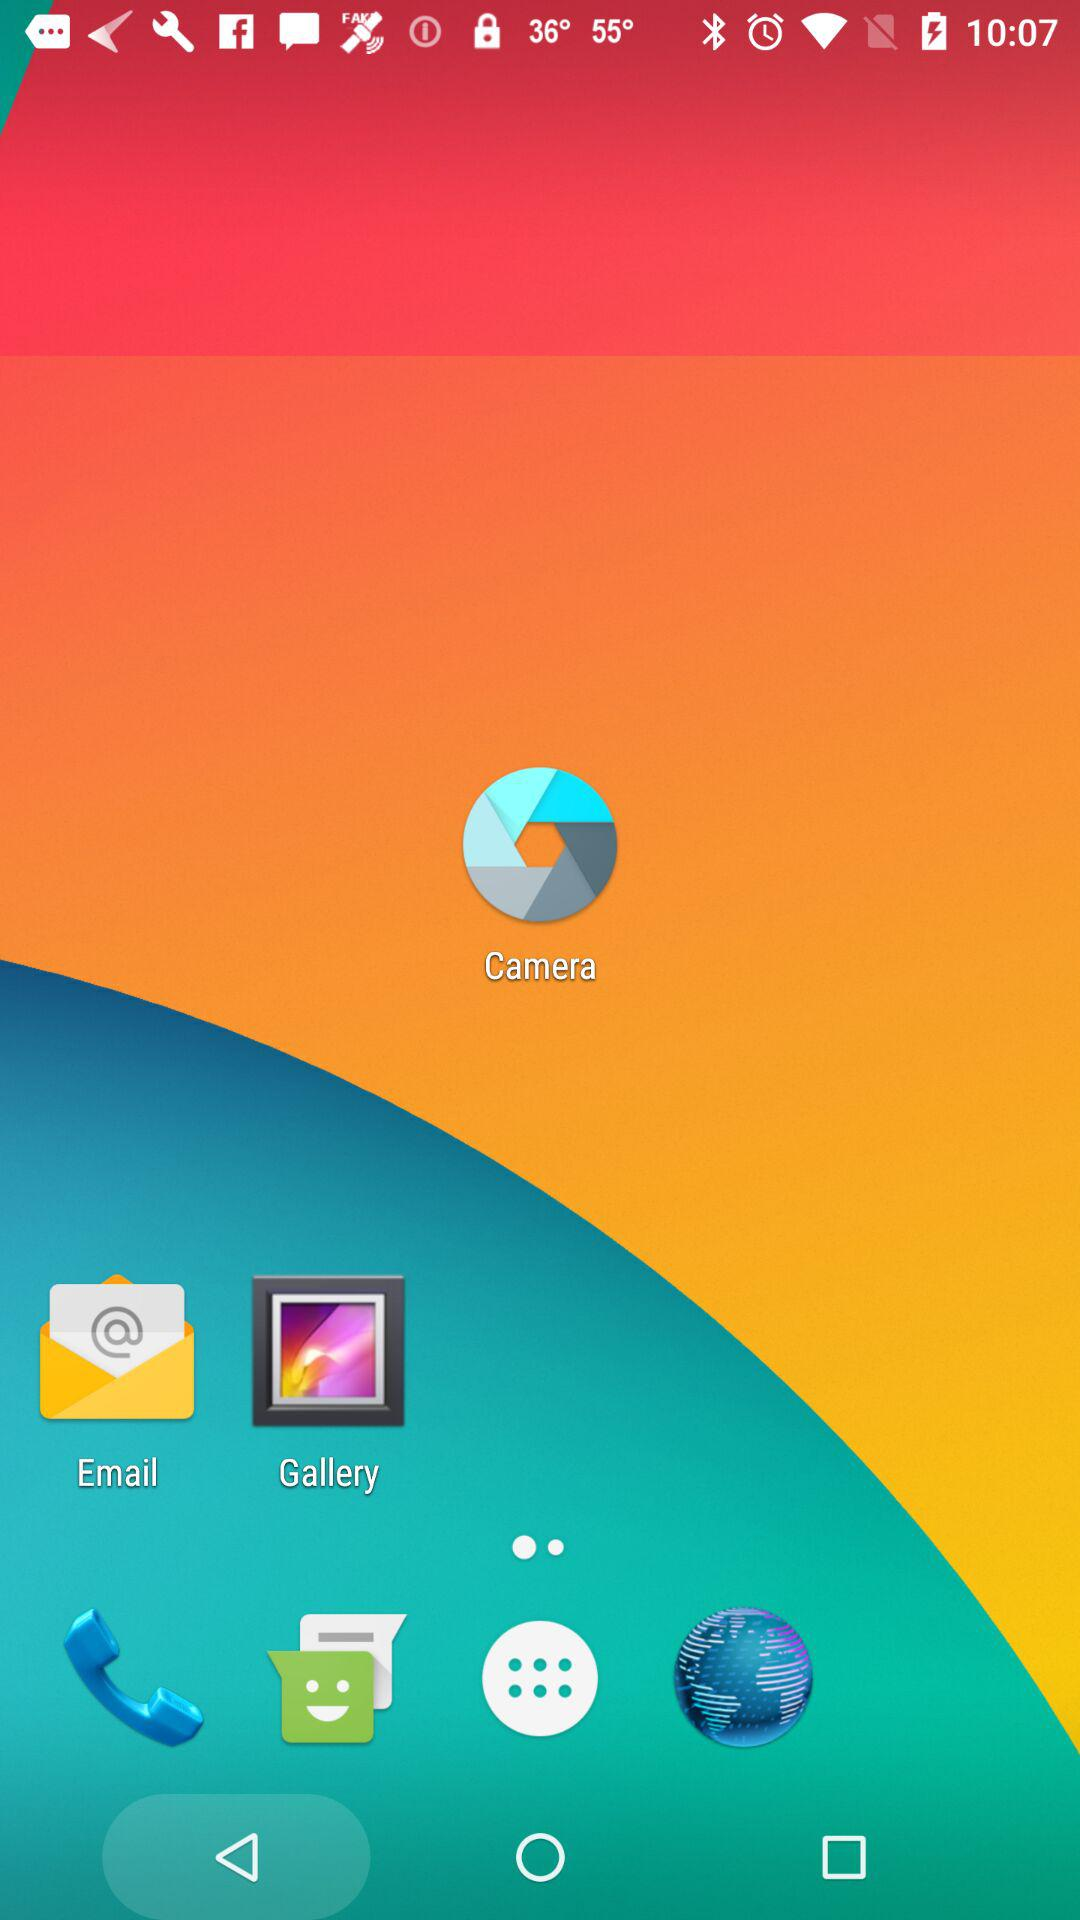How many total states are there? There are 50 total states. 